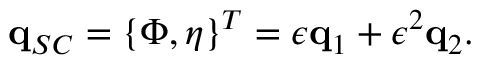Convert formula to latex. <formula><loc_0><loc_0><loc_500><loc_500>q _ { S C } = \left \{ \Phi , \eta \right \} ^ { T } = \epsilon q _ { 1 } + \epsilon ^ { 2 } q _ { 2 } .</formula> 